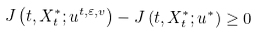Convert formula to latex. <formula><loc_0><loc_0><loc_500><loc_500>J \left ( t , X _ { t } ^ { * } ; u ^ { t , \varepsilon , v } \right ) - J \left ( t , X _ { t } ^ { * } ; u ^ { * } \right ) \geq 0</formula> 